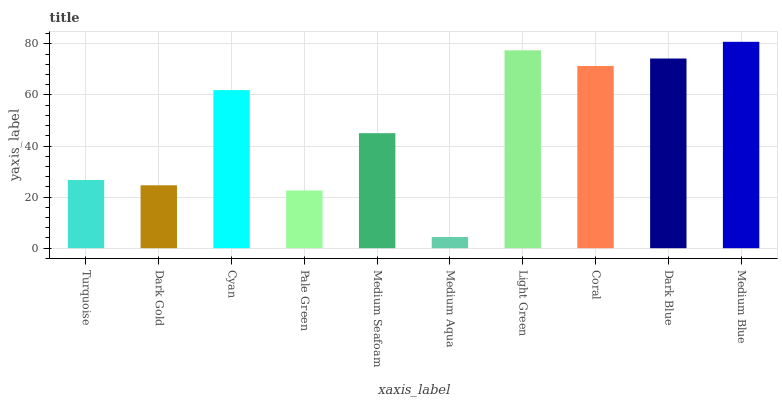Is Medium Aqua the minimum?
Answer yes or no. Yes. Is Medium Blue the maximum?
Answer yes or no. Yes. Is Dark Gold the minimum?
Answer yes or no. No. Is Dark Gold the maximum?
Answer yes or no. No. Is Turquoise greater than Dark Gold?
Answer yes or no. Yes. Is Dark Gold less than Turquoise?
Answer yes or no. Yes. Is Dark Gold greater than Turquoise?
Answer yes or no. No. Is Turquoise less than Dark Gold?
Answer yes or no. No. Is Cyan the high median?
Answer yes or no. Yes. Is Medium Seafoam the low median?
Answer yes or no. Yes. Is Dark Blue the high median?
Answer yes or no. No. Is Turquoise the low median?
Answer yes or no. No. 